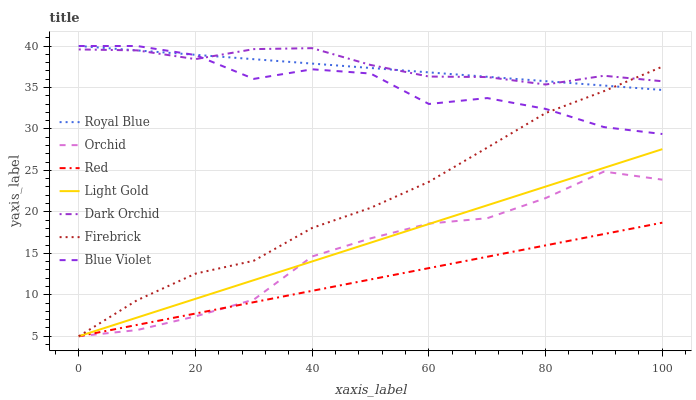Does Red have the minimum area under the curve?
Answer yes or no. Yes. Does Dark Orchid have the maximum area under the curve?
Answer yes or no. Yes. Does Royal Blue have the minimum area under the curve?
Answer yes or no. No. Does Royal Blue have the maximum area under the curve?
Answer yes or no. No. Is Royal Blue the smoothest?
Answer yes or no. Yes. Is Blue Violet the roughest?
Answer yes or no. Yes. Is Dark Orchid the smoothest?
Answer yes or no. No. Is Dark Orchid the roughest?
Answer yes or no. No. Does Firebrick have the lowest value?
Answer yes or no. Yes. Does Royal Blue have the lowest value?
Answer yes or no. No. Does Blue Violet have the highest value?
Answer yes or no. Yes. Does Dark Orchid have the highest value?
Answer yes or no. No. Is Light Gold less than Dark Orchid?
Answer yes or no. Yes. Is Royal Blue greater than Orchid?
Answer yes or no. Yes. Does Dark Orchid intersect Royal Blue?
Answer yes or no. Yes. Is Dark Orchid less than Royal Blue?
Answer yes or no. No. Is Dark Orchid greater than Royal Blue?
Answer yes or no. No. Does Light Gold intersect Dark Orchid?
Answer yes or no. No. 